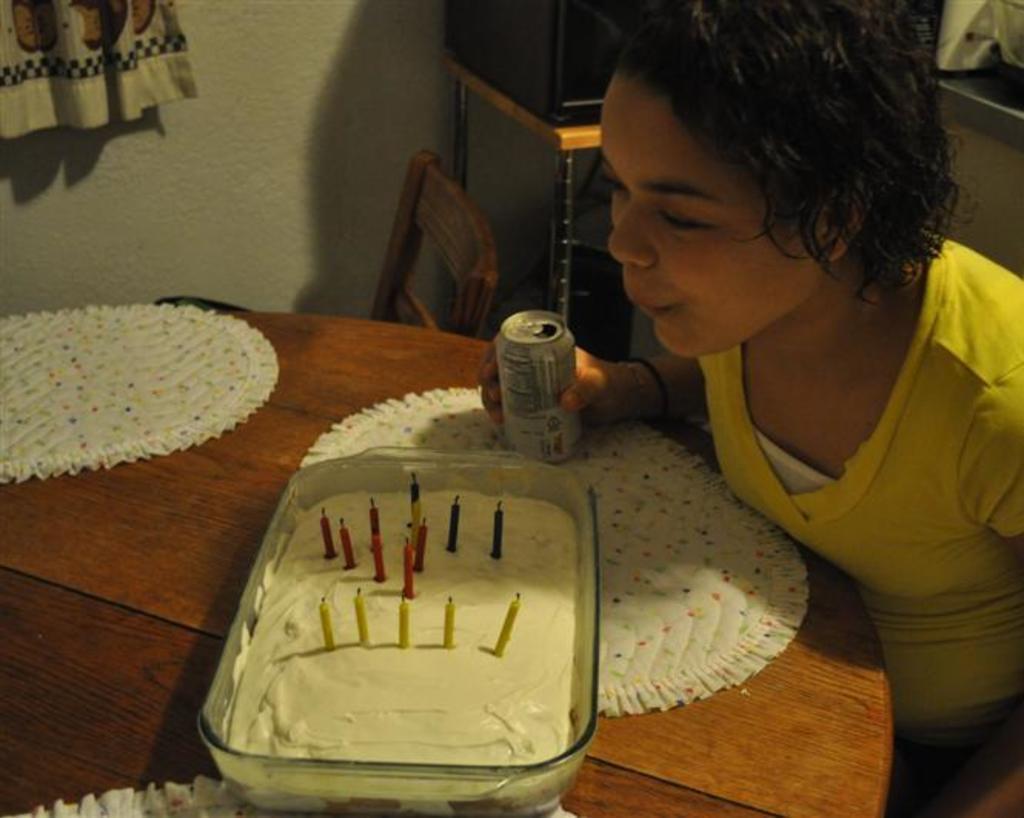How would you summarize this image in a sentence or two? This image is clicked in a room. There is a bowl and cake in that. There are candles in that. There is a tin. There is a person sitting near the table. There is a television on the backside on the table. 